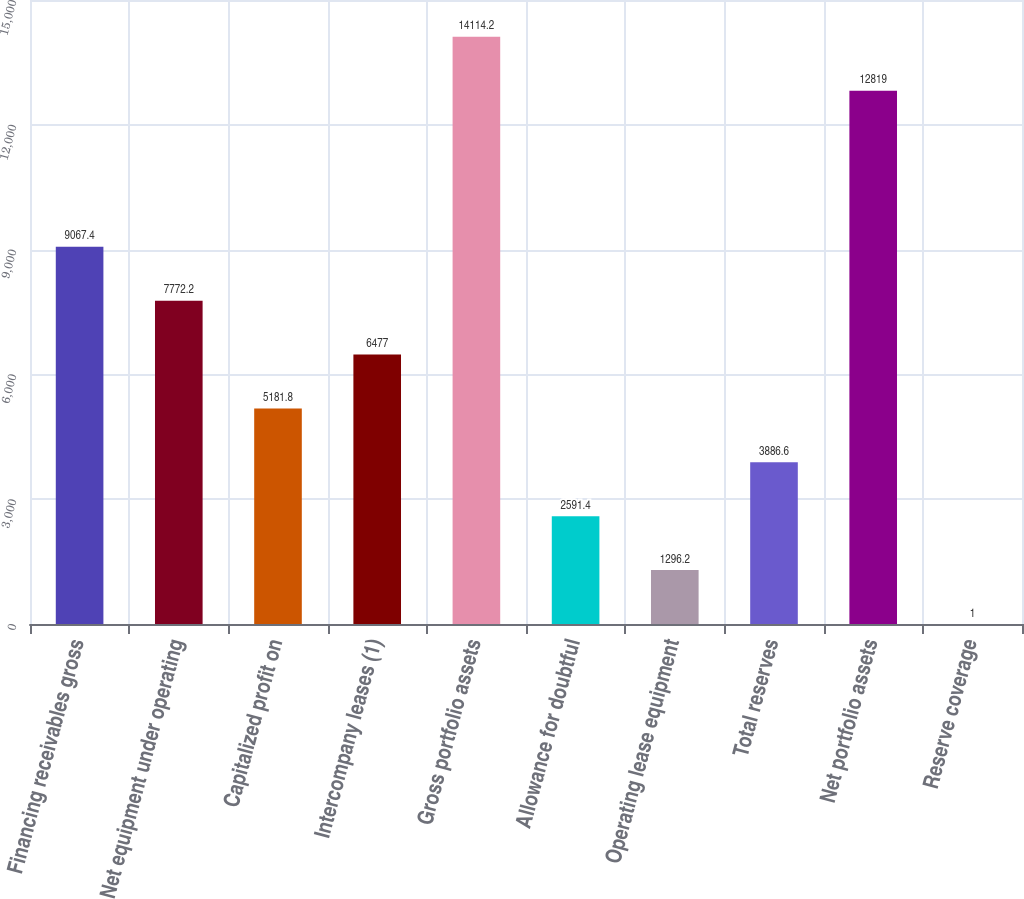Convert chart to OTSL. <chart><loc_0><loc_0><loc_500><loc_500><bar_chart><fcel>Financing receivables gross<fcel>Net equipment under operating<fcel>Capitalized profit on<fcel>Intercompany leases (1)<fcel>Gross portfolio assets<fcel>Allowance for doubtful<fcel>Operating lease equipment<fcel>Total reserves<fcel>Net portfolio assets<fcel>Reserve coverage<nl><fcel>9067.4<fcel>7772.2<fcel>5181.8<fcel>6477<fcel>14114.2<fcel>2591.4<fcel>1296.2<fcel>3886.6<fcel>12819<fcel>1<nl></chart> 